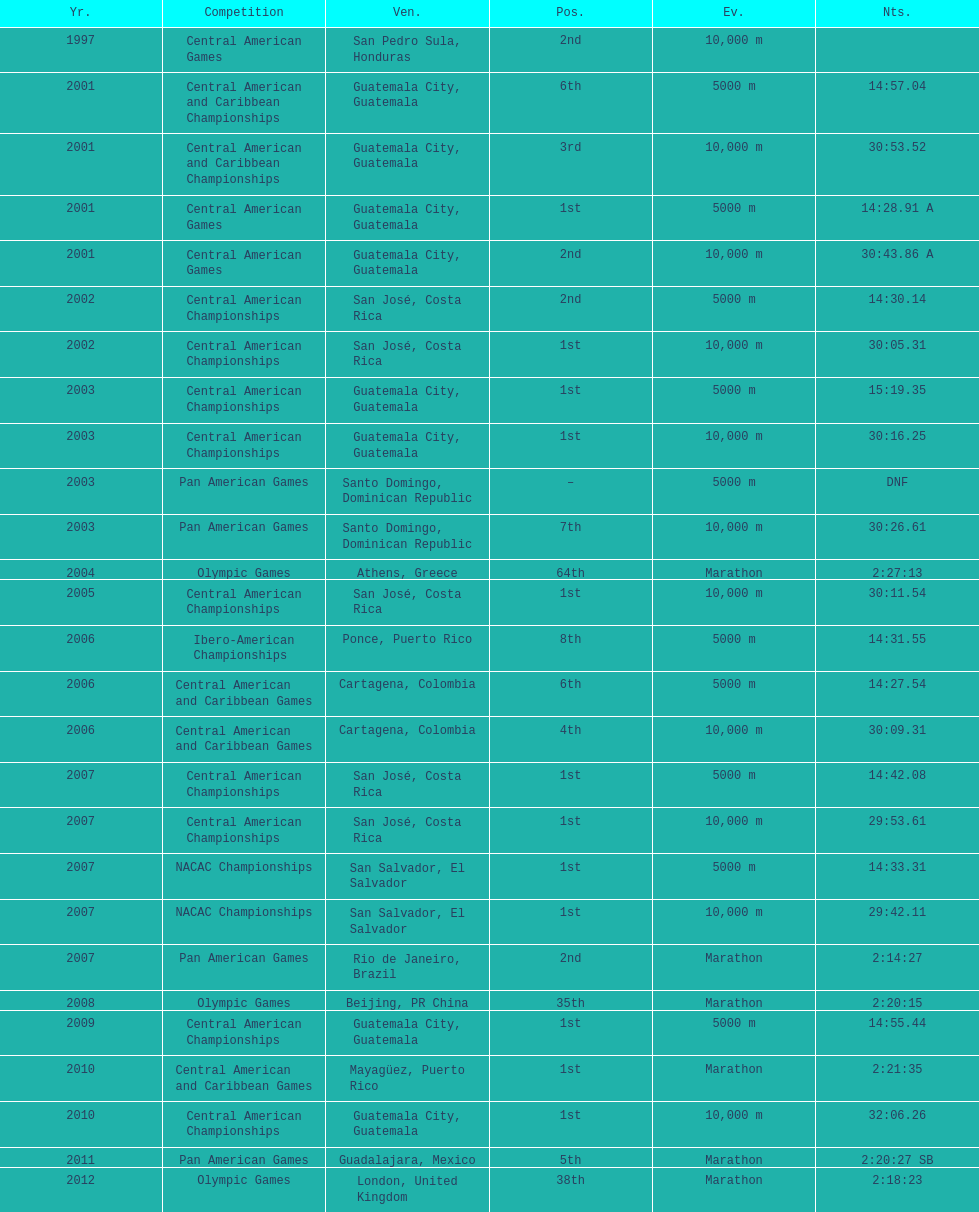What was the first competition this competitor competed in? Central American Games. 